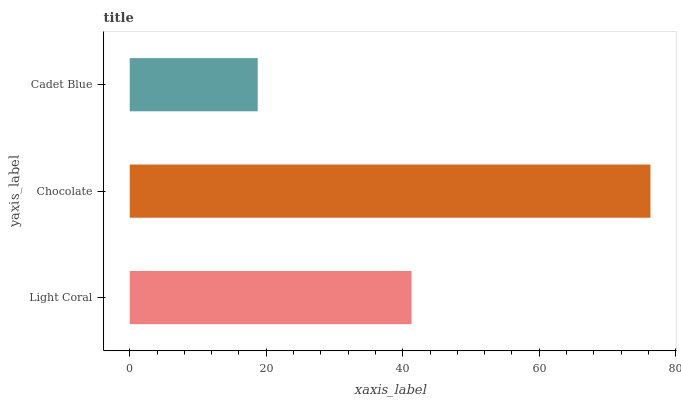Is Cadet Blue the minimum?
Answer yes or no. Yes. Is Chocolate the maximum?
Answer yes or no. Yes. Is Chocolate the minimum?
Answer yes or no. No. Is Cadet Blue the maximum?
Answer yes or no. No. Is Chocolate greater than Cadet Blue?
Answer yes or no. Yes. Is Cadet Blue less than Chocolate?
Answer yes or no. Yes. Is Cadet Blue greater than Chocolate?
Answer yes or no. No. Is Chocolate less than Cadet Blue?
Answer yes or no. No. Is Light Coral the high median?
Answer yes or no. Yes. Is Light Coral the low median?
Answer yes or no. Yes. Is Cadet Blue the high median?
Answer yes or no. No. Is Chocolate the low median?
Answer yes or no. No. 